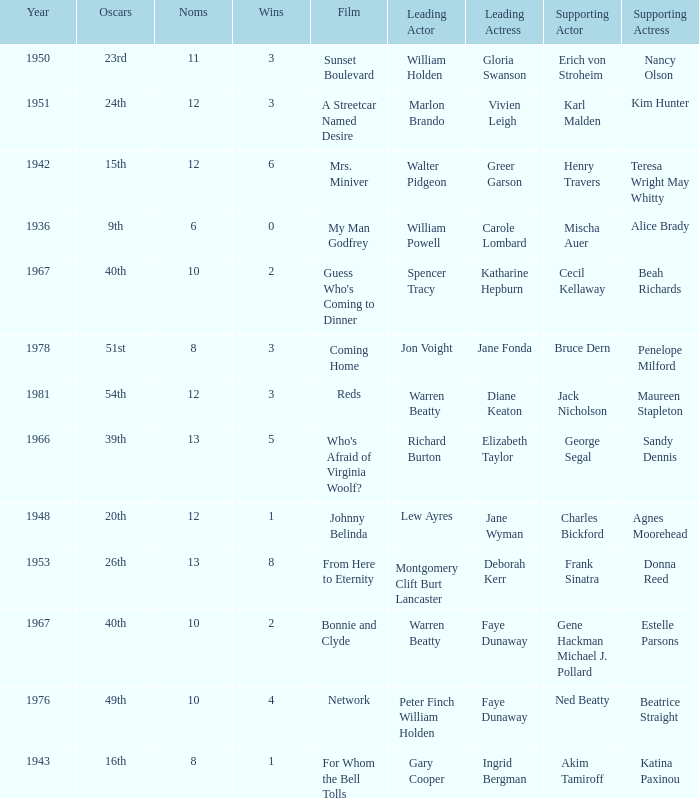Would you mind parsing the complete table? {'header': ['Year', 'Oscars', 'Noms', 'Wins', 'Film', 'Leading Actor', 'Leading Actress', 'Supporting Actor', 'Supporting Actress'], 'rows': [['1950', '23rd', '11', '3', 'Sunset Boulevard', 'William Holden', 'Gloria Swanson', 'Erich von Stroheim', 'Nancy Olson'], ['1951', '24th', '12', '3', 'A Streetcar Named Desire', 'Marlon Brando', 'Vivien Leigh', 'Karl Malden', 'Kim Hunter'], ['1942', '15th', '12', '6', 'Mrs. Miniver', 'Walter Pidgeon', 'Greer Garson', 'Henry Travers', 'Teresa Wright May Whitty'], ['1936', '9th', '6', '0', 'My Man Godfrey', 'William Powell', 'Carole Lombard', 'Mischa Auer', 'Alice Brady'], ['1967', '40th', '10', '2', "Guess Who's Coming to Dinner", 'Spencer Tracy', 'Katharine Hepburn', 'Cecil Kellaway', 'Beah Richards'], ['1978', '51st', '8', '3', 'Coming Home', 'Jon Voight', 'Jane Fonda', 'Bruce Dern', 'Penelope Milford'], ['1981', '54th', '12', '3', 'Reds', 'Warren Beatty', 'Diane Keaton', 'Jack Nicholson', 'Maureen Stapleton'], ['1966', '39th', '13', '5', "Who's Afraid of Virginia Woolf?", 'Richard Burton', 'Elizabeth Taylor', 'George Segal', 'Sandy Dennis'], ['1948', '20th', '12', '1', 'Johnny Belinda', 'Lew Ayres', 'Jane Wyman', 'Charles Bickford', 'Agnes Moorehead'], ['1953', '26th', '13', '8', 'From Here to Eternity', 'Montgomery Clift Burt Lancaster', 'Deborah Kerr', 'Frank Sinatra', 'Donna Reed'], ['1967', '40th', '10', '2', 'Bonnie and Clyde', 'Warren Beatty', 'Faye Dunaway', 'Gene Hackman Michael J. Pollard', 'Estelle Parsons'], ['1976', '49th', '10', '4', 'Network', 'Peter Finch William Holden', 'Faye Dunaway', 'Ned Beatty', 'Beatrice Straight'], ['1943', '16th', '8', '1', 'For Whom the Bell Tolls', 'Gary Cooper', 'Ingrid Bergman', 'Akim Tamiroff', 'Katina Paxinou']]} Who was the supporting actress in 1943? Katina Paxinou. 